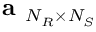<formula> <loc_0><loc_0><loc_500><loc_500>a _ { N _ { R } \times N _ { S } }</formula> 